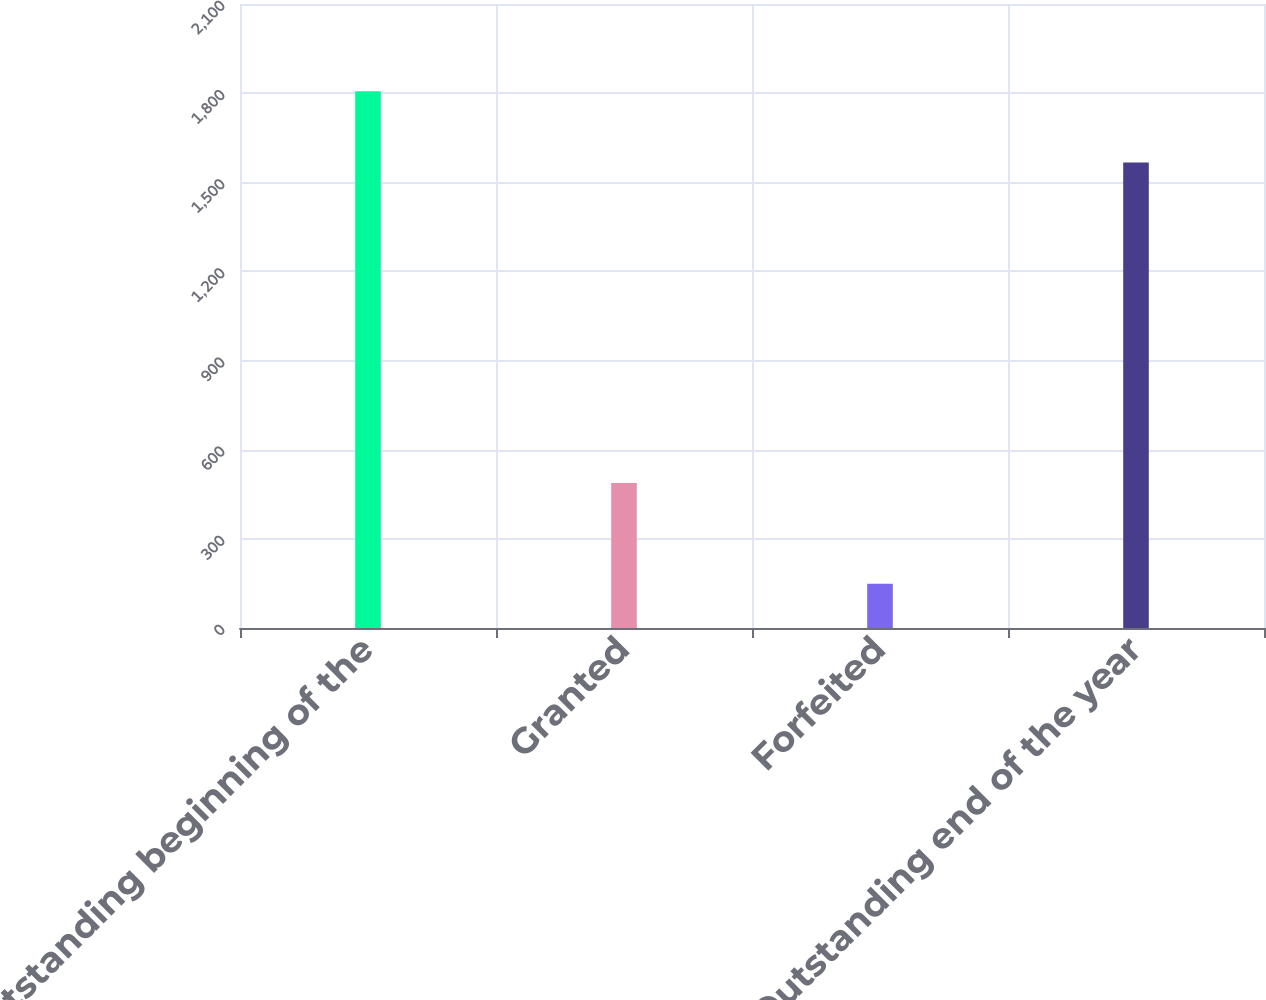Convert chart to OTSL. <chart><loc_0><loc_0><loc_500><loc_500><bar_chart><fcel>Outstanding beginning of the<fcel>Granted<fcel>Forfeited<fcel>Outstanding end of the year<nl><fcel>1806<fcel>488<fcel>149<fcel>1567<nl></chart> 